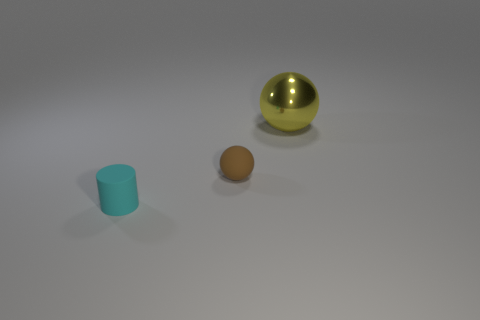How large do you estimate the objects to be in relation to each other? Judging by their relative sizes in the image, the gold-colored sphere seems to be the largest object, followed by the yellow ball, which is distinctly smaller. The small cylinder is the smallest of the three, with both its height and diameter appearing to be less than half the diameter of the yellow ball. 